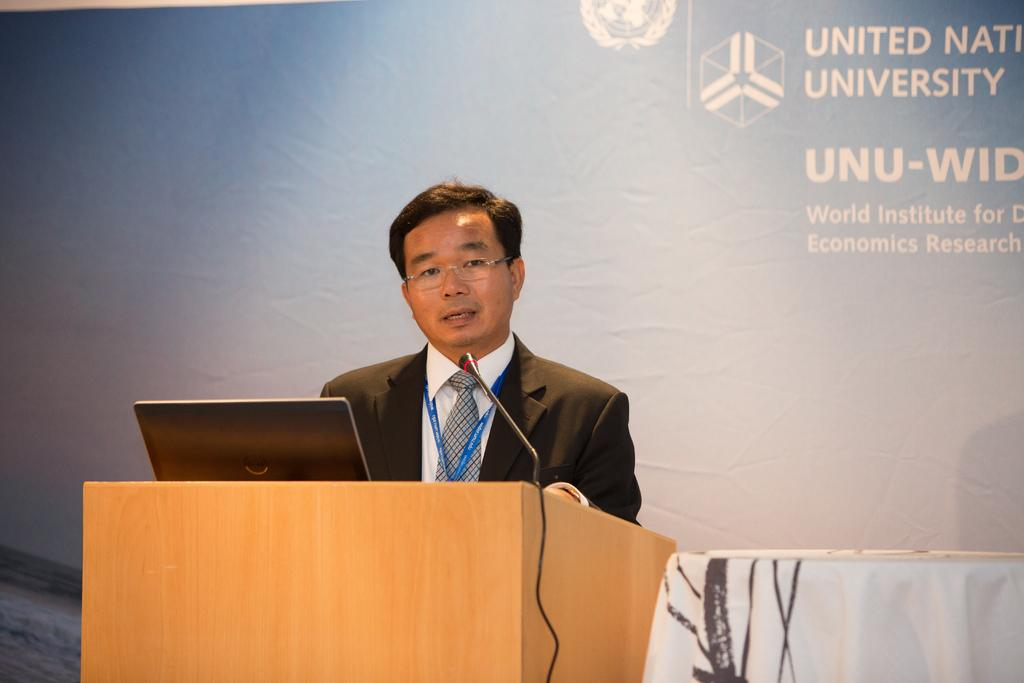What is the person in the image doing? The person is standing at a desk in the image. What can be seen on the desk? The desk has a laptop and a microphone (mic) on it. What is visible in the background of the image? There is an advertisement visible in the background of the image. What type of hose is being used to water the plants in the image? There are no plants or hoses present in the image; it features a person standing at a desk with a laptop and a microphone. 